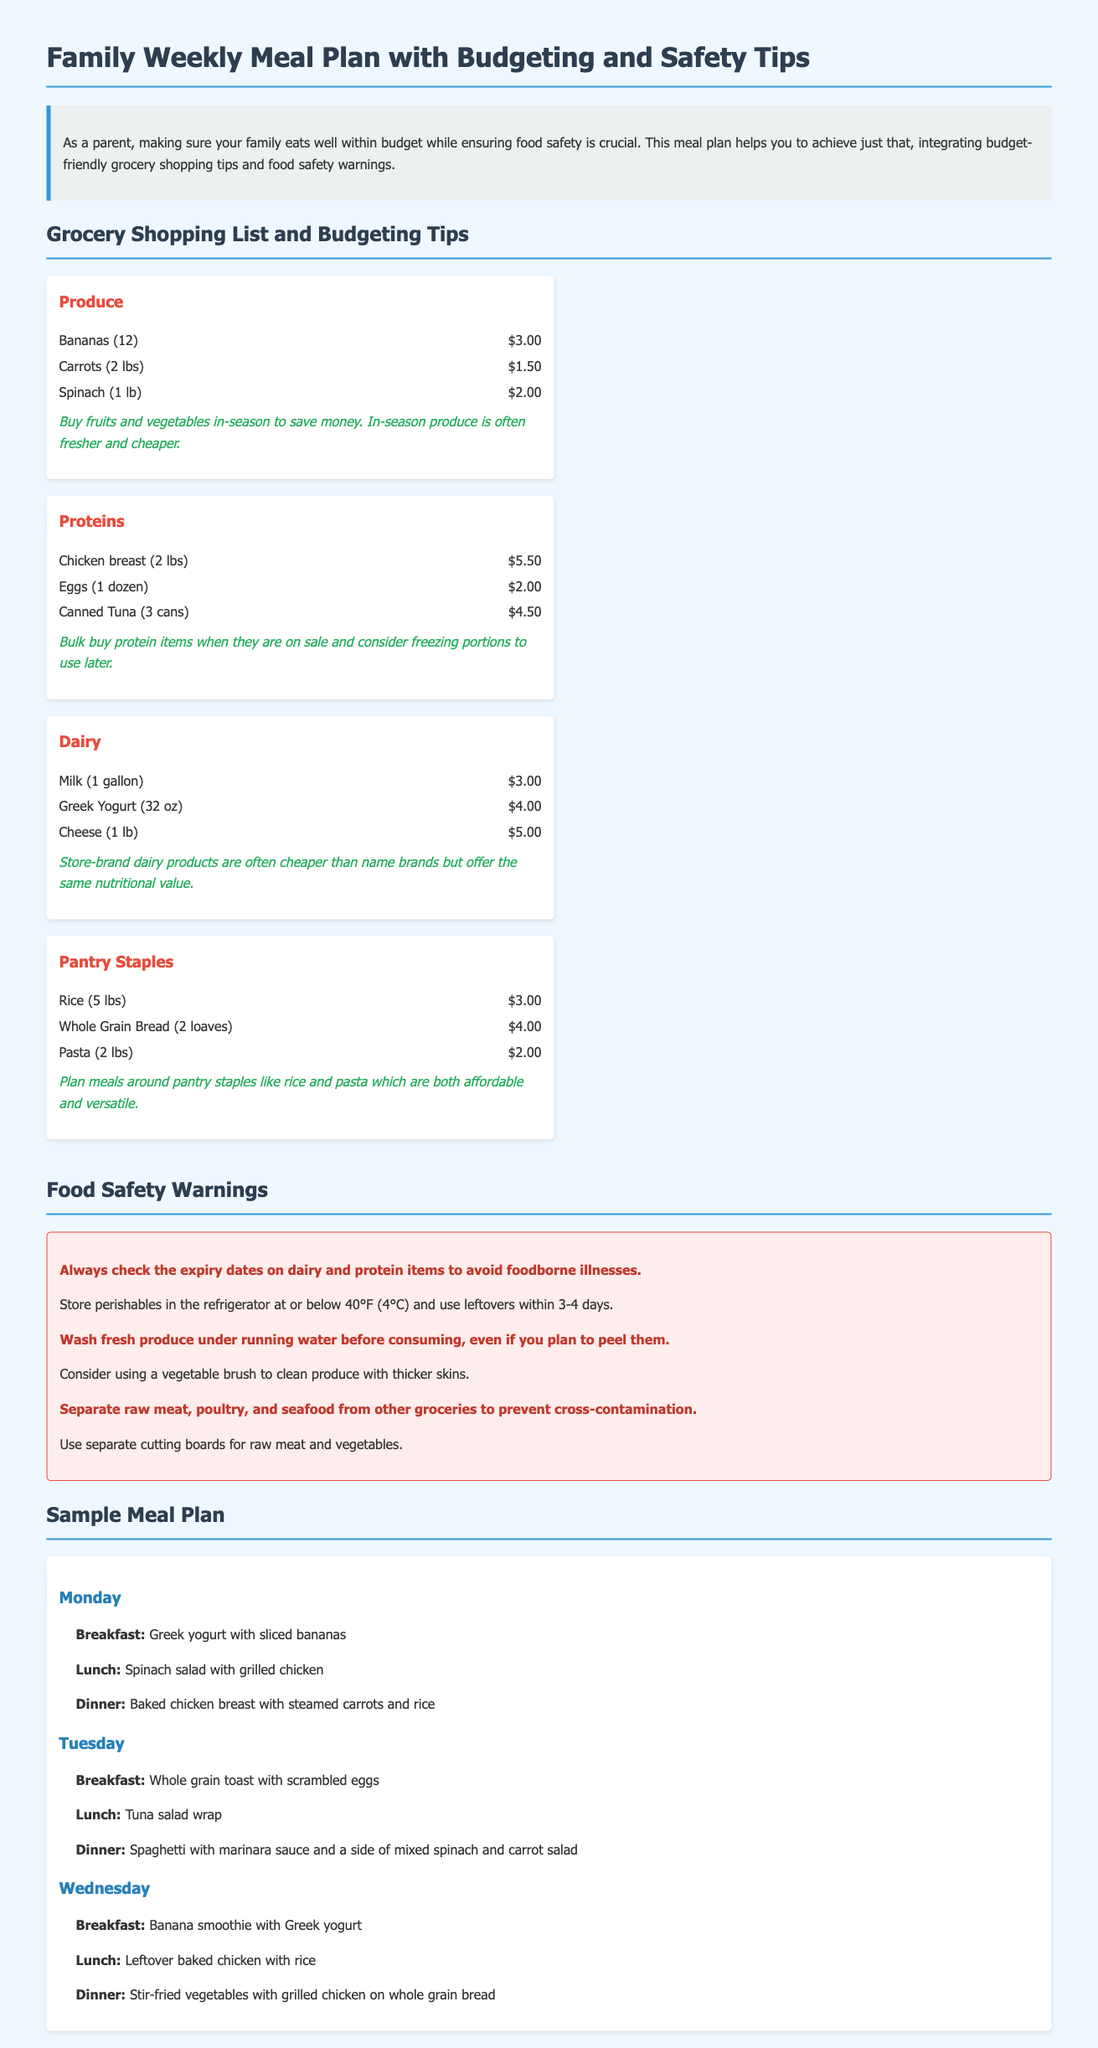What is the total cost of Bananas? The total cost of Bananas is stated in the document as $3.00.
Answer: $3.00 How many pounds of Carrots are listed? The document indicates that 2 lbs of Carrots are included in the grocery list.
Answer: 2 lbs What meal is suggested for Wednesday breakfast? The document specifies that the suggested meal for Wednesday breakfast is a Banana smoothie with Greek yogurt.
Answer: Banana smoothie with Greek yogurt What safety warning is associated with raw meat? The document highlights that raw meat, poultry, and seafood should be kept separate from other groceries to prevent cross-contamination.
Answer: Prevent cross-contamination What budgeting tip is provided for produce? The document advises buying fruits and vegetables in-season to save money.
Answer: Buy fruits and vegetables in-season 